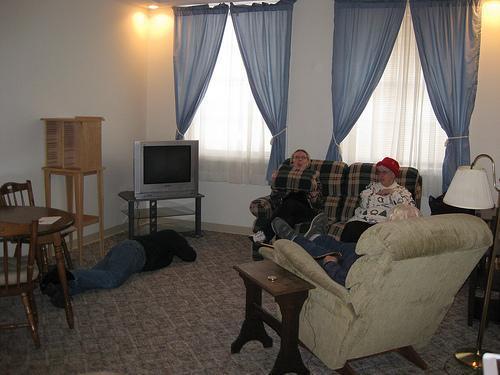How many people are there?
Give a very brief answer. 4. How many seats in this image have no one sitting in them?
Give a very brief answer. 2. How many people are laying on the floor?
Give a very brief answer. 1. 